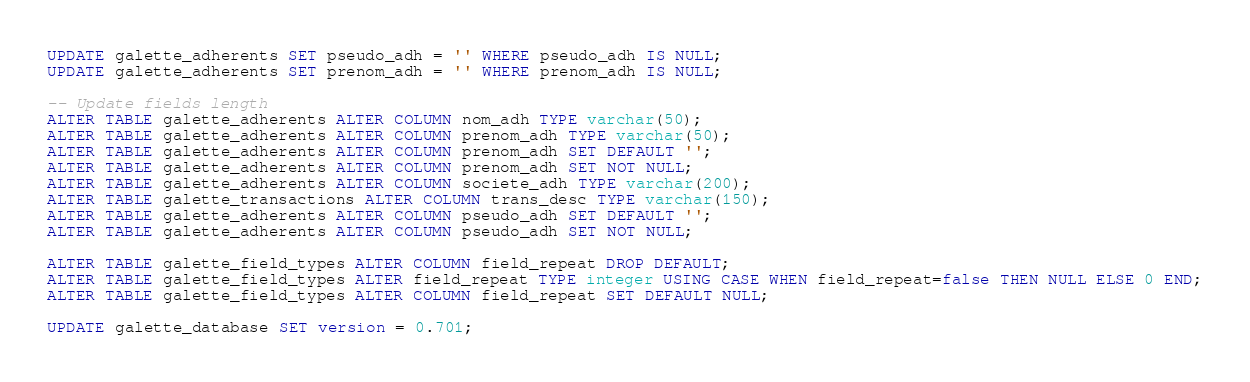<code> <loc_0><loc_0><loc_500><loc_500><_SQL_>UPDATE galette_adherents SET pseudo_adh = '' WHERE pseudo_adh IS NULL;
UPDATE galette_adherents SET prenom_adh = '' WHERE prenom_adh IS NULL;

-- Update fields length
ALTER TABLE galette_adherents ALTER COLUMN nom_adh TYPE varchar(50);
ALTER TABLE galette_adherents ALTER COLUMN prenom_adh TYPE varchar(50);
ALTER TABLE galette_adherents ALTER COLUMN prenom_adh SET DEFAULT '';
ALTER TABLE galette_adherents ALTER COLUMN prenom_adh SET NOT NULL;
ALTER TABLE galette_adherents ALTER COLUMN societe_adh TYPE varchar(200);
ALTER TABLE galette_transactions ALTER COLUMN trans_desc TYPE varchar(150);
ALTER TABLE galette_adherents ALTER COLUMN pseudo_adh SET DEFAULT '';
ALTER TABLE galette_adherents ALTER COLUMN pseudo_adh SET NOT NULL;

ALTER TABLE galette_field_types ALTER COLUMN field_repeat DROP DEFAULT;
ALTER TABLE galette_field_types ALTER field_repeat TYPE integer USING CASE WHEN field_repeat=false THEN NULL ELSE 0 END;
ALTER TABLE galette_field_types ALTER COLUMN field_repeat SET DEFAULT NULL;

UPDATE galette_database SET version = 0.701;
</code> 